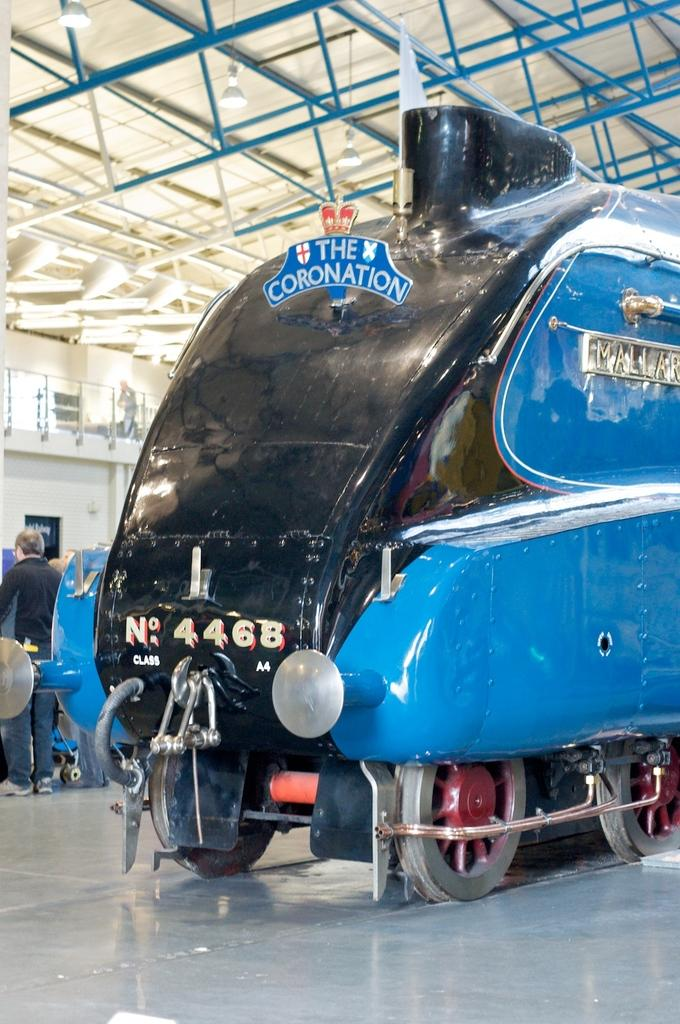What is the main subject of the image? There is a vehicle in the image. Are there any people present in the image? Yes, there are people in the image. What type of structure can be seen in the image? There is a wall with fencing in the image. Can you describe the lighting in the image? There are lights in the image, and there are also lights on the roof. What type of birds can be seen in the aftermath of the event in the image? There is no event or aftermath depicted in the image, and there are no birds present. 